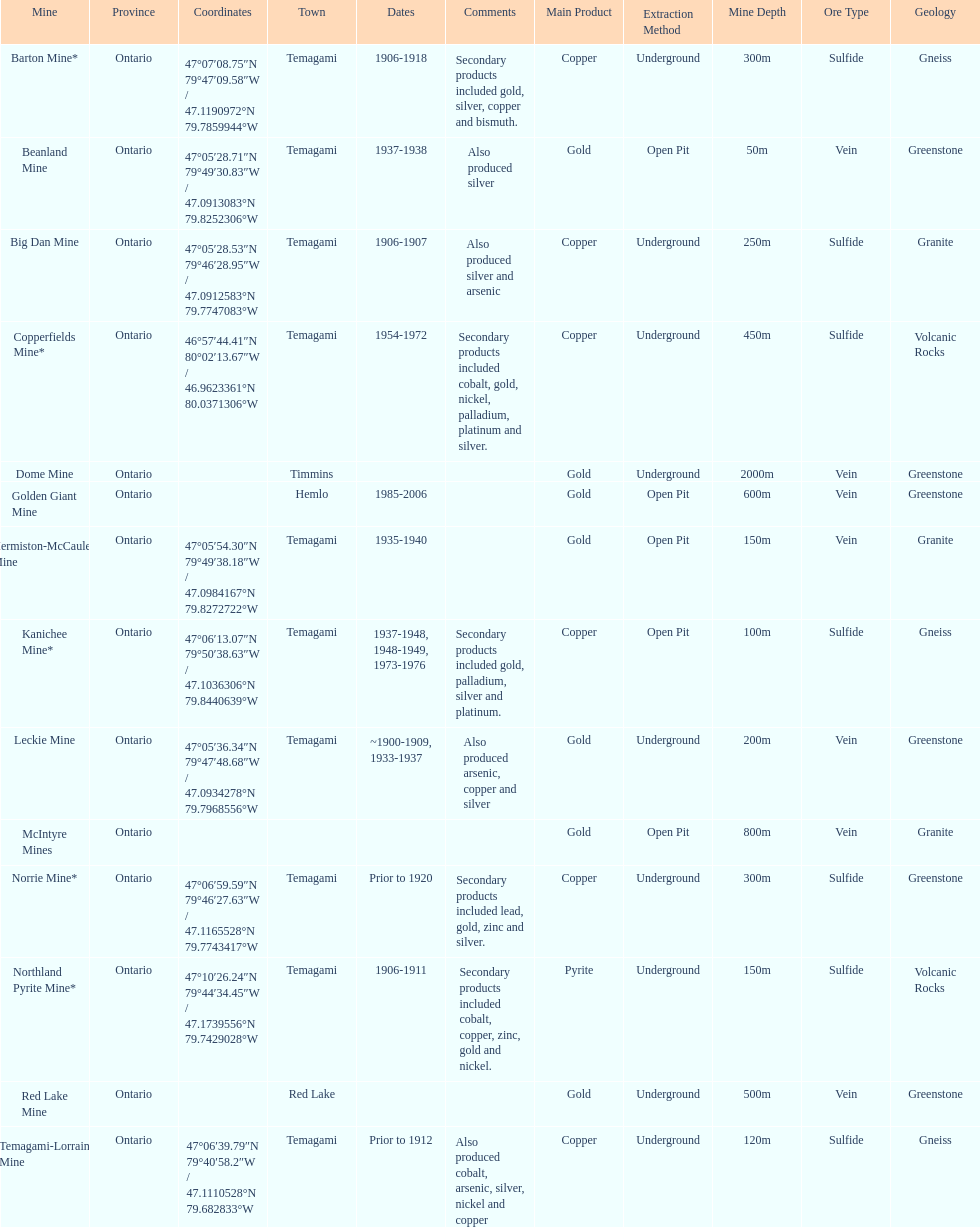In what mine could you find bismuth? Barton Mine. 